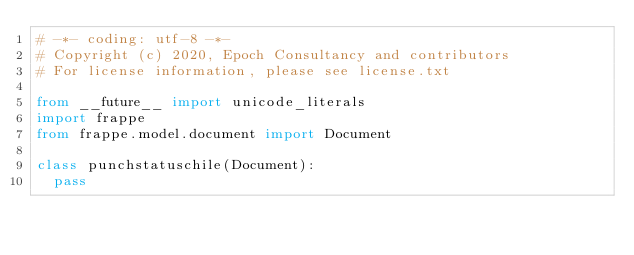Convert code to text. <code><loc_0><loc_0><loc_500><loc_500><_Python_># -*- coding: utf-8 -*-
# Copyright (c) 2020, Epoch Consultancy and contributors
# For license information, please see license.txt

from __future__ import unicode_literals
import frappe
from frappe.model.document import Document

class punchstatuschile(Document):
	pass
</code> 